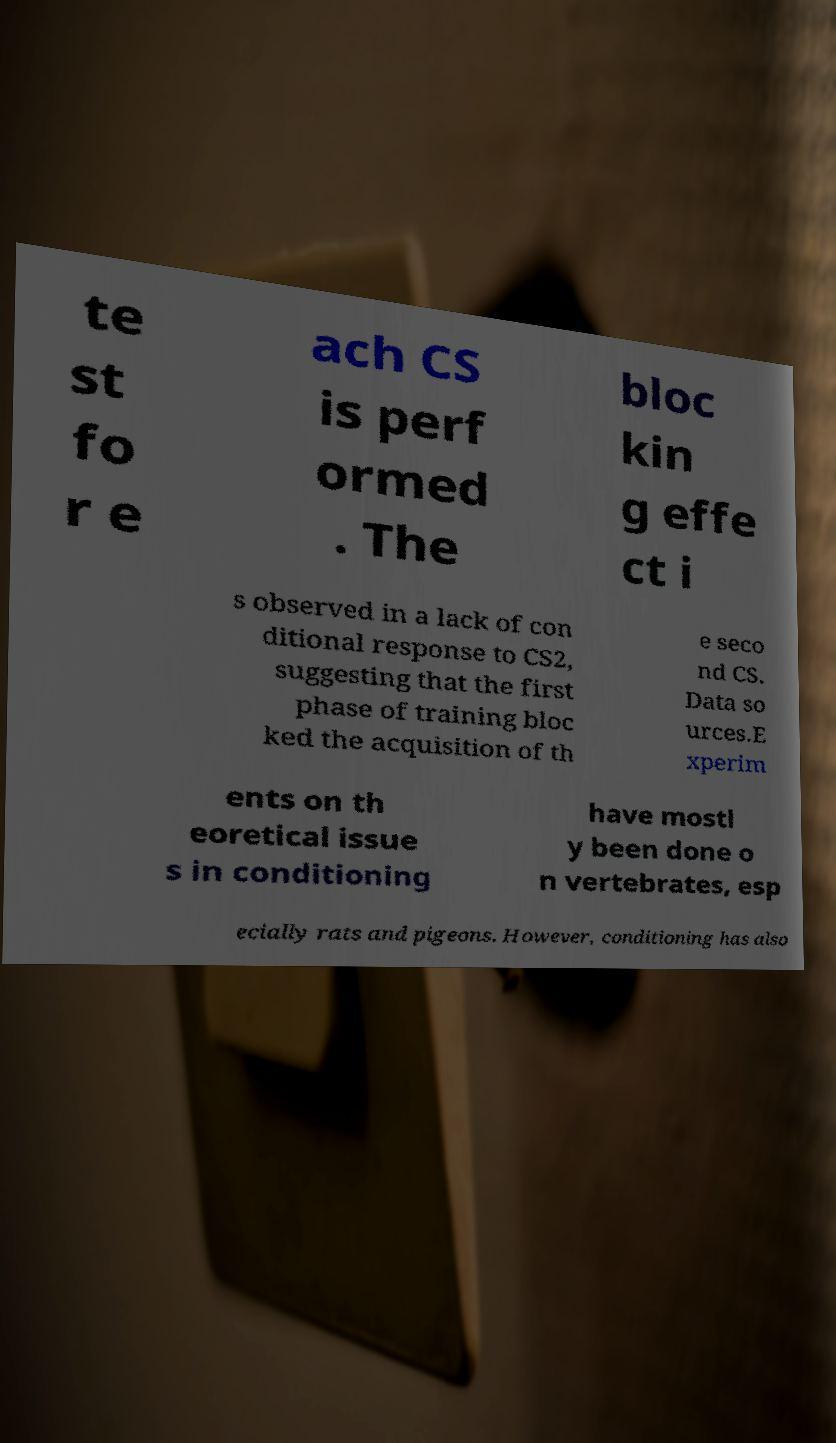Could you extract and type out the text from this image? te st fo r e ach CS is perf ormed . The bloc kin g effe ct i s observed in a lack of con ditional response to CS2, suggesting that the first phase of training bloc ked the acquisition of th e seco nd CS. Data so urces.E xperim ents on th eoretical issue s in conditioning have mostl y been done o n vertebrates, esp ecially rats and pigeons. However, conditioning has also 